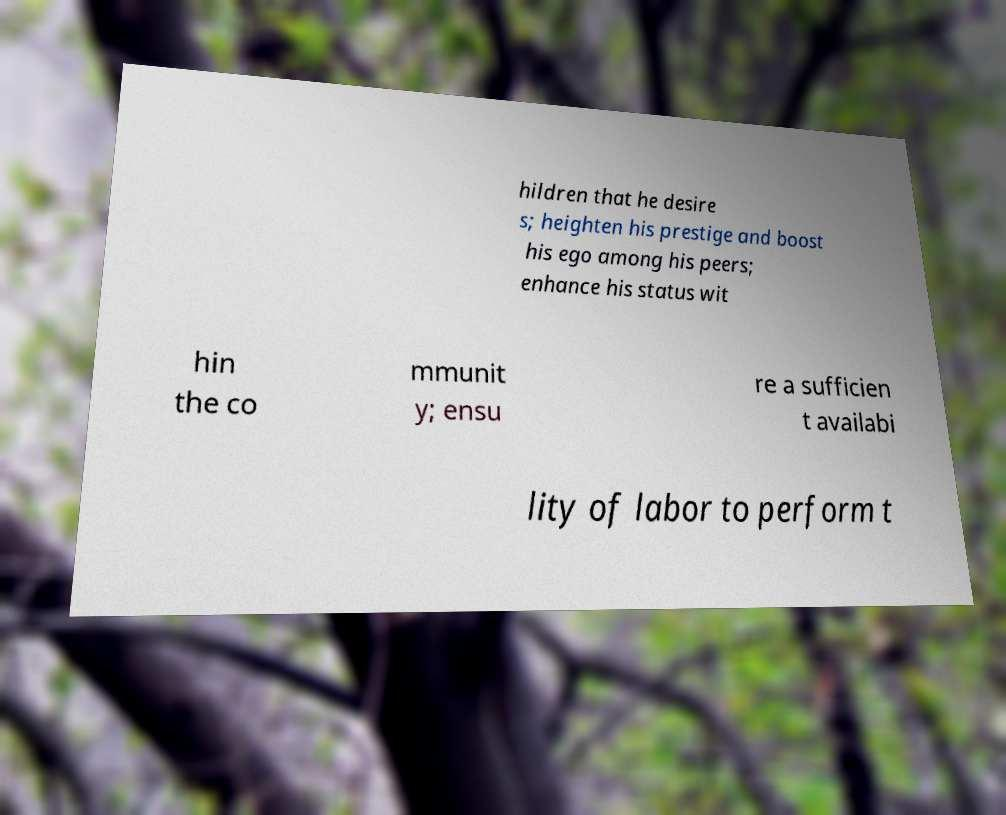I need the written content from this picture converted into text. Can you do that? hildren that he desire s; heighten his prestige and boost his ego among his peers; enhance his status wit hin the co mmunit y; ensu re a sufficien t availabi lity of labor to perform t 